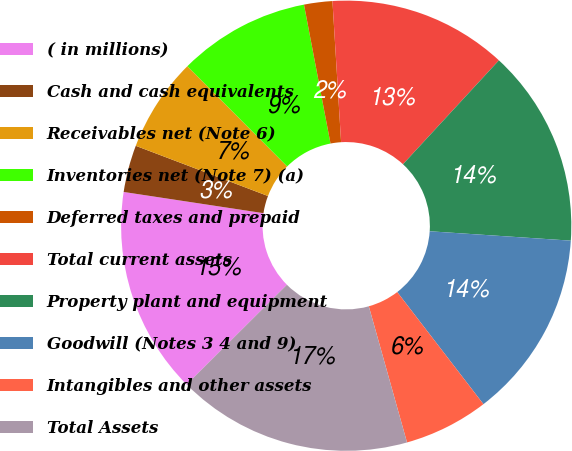Convert chart. <chart><loc_0><loc_0><loc_500><loc_500><pie_chart><fcel>( in millions)<fcel>Cash and cash equivalents<fcel>Receivables net (Note 6)<fcel>Inventories net (Note 7) (a)<fcel>Deferred taxes and prepaid<fcel>Total current assets<fcel>Property plant and equipment<fcel>Goodwill (Notes 3 4 and 9)<fcel>Intangibles and other assets<fcel>Total Assets<nl><fcel>14.86%<fcel>3.38%<fcel>6.76%<fcel>9.46%<fcel>2.03%<fcel>12.84%<fcel>14.19%<fcel>13.51%<fcel>6.08%<fcel>16.89%<nl></chart> 